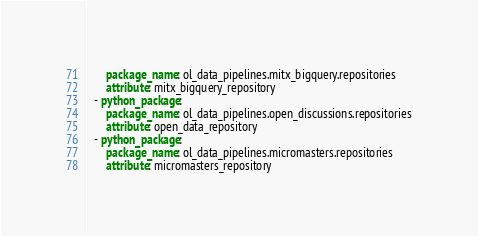<code> <loc_0><loc_0><loc_500><loc_500><_YAML_>      package_name: ol_data_pipelines.mitx_bigquery.repositories
      attribute: mitx_bigquery_repository
  - python_package:
      package_name: ol_data_pipelines.open_discussions.repositories
      attribute: open_data_repository
  - python_package:
      package_name: ol_data_pipelines.micromasters.repositories
      attribute: micromasters_repository
</code> 